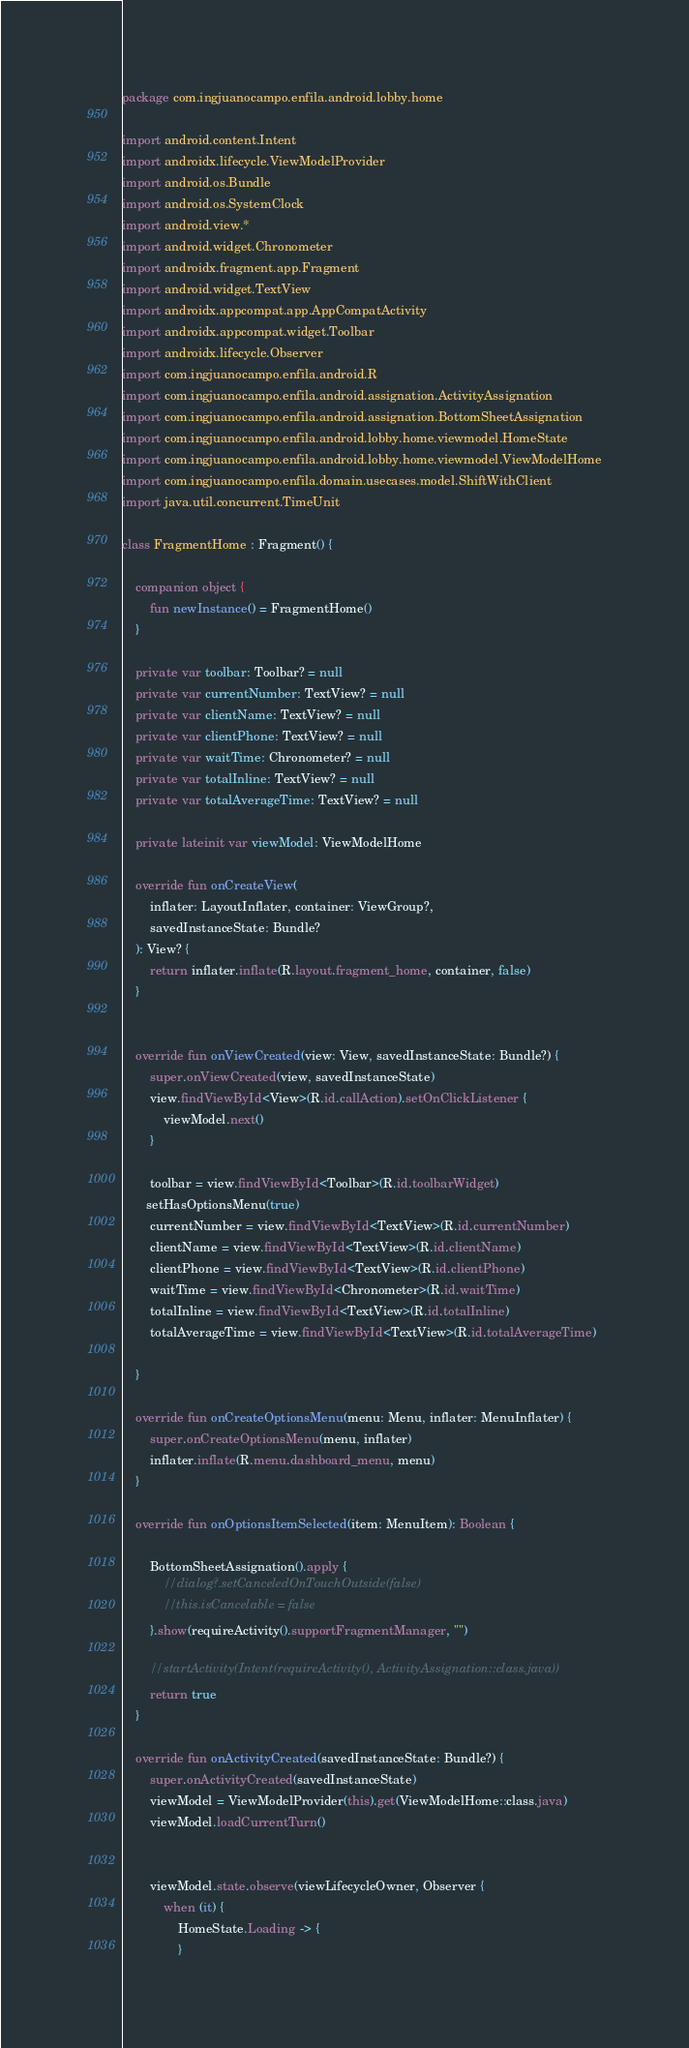<code> <loc_0><loc_0><loc_500><loc_500><_Kotlin_>package com.ingjuanocampo.enfila.android.lobby.home

import android.content.Intent
import androidx.lifecycle.ViewModelProvider
import android.os.Bundle
import android.os.SystemClock
import android.view.*
import android.widget.Chronometer
import androidx.fragment.app.Fragment
import android.widget.TextView
import androidx.appcompat.app.AppCompatActivity
import androidx.appcompat.widget.Toolbar
import androidx.lifecycle.Observer
import com.ingjuanocampo.enfila.android.R
import com.ingjuanocampo.enfila.android.assignation.ActivityAssignation
import com.ingjuanocampo.enfila.android.assignation.BottomSheetAssignation
import com.ingjuanocampo.enfila.android.lobby.home.viewmodel.HomeState
import com.ingjuanocampo.enfila.android.lobby.home.viewmodel.ViewModelHome
import com.ingjuanocampo.enfila.domain.usecases.model.ShiftWithClient
import java.util.concurrent.TimeUnit

class FragmentHome : Fragment() {

    companion object {
        fun newInstance() = FragmentHome()
    }

    private var toolbar: Toolbar? = null
    private var currentNumber: TextView? = null
    private var clientName: TextView? = null
    private var clientPhone: TextView? = null
    private var waitTime: Chronometer? = null
    private var totalInline: TextView? = null
    private var totalAverageTime: TextView? = null

    private lateinit var viewModel: ViewModelHome

    override fun onCreateView(
        inflater: LayoutInflater, container: ViewGroup?,
        savedInstanceState: Bundle?
    ): View? {
        return inflater.inflate(R.layout.fragment_home, container, false)
    }


    override fun onViewCreated(view: View, savedInstanceState: Bundle?) {
        super.onViewCreated(view, savedInstanceState)
        view.findViewById<View>(R.id.callAction).setOnClickListener {
            viewModel.next()
        }

        toolbar = view.findViewById<Toolbar>(R.id.toolbarWidget)
       setHasOptionsMenu(true)
        currentNumber = view.findViewById<TextView>(R.id.currentNumber)
        clientName = view.findViewById<TextView>(R.id.clientName)
        clientPhone = view.findViewById<TextView>(R.id.clientPhone)
        waitTime = view.findViewById<Chronometer>(R.id.waitTime)
        totalInline = view.findViewById<TextView>(R.id.totalInline)
        totalAverageTime = view.findViewById<TextView>(R.id.totalAverageTime)

    }

    override fun onCreateOptionsMenu(menu: Menu, inflater: MenuInflater) {
        super.onCreateOptionsMenu(menu, inflater)
        inflater.inflate(R.menu.dashboard_menu, menu)
    }

    override fun onOptionsItemSelected(item: MenuItem): Boolean {

        BottomSheetAssignation().apply {
            //dialog?.setCanceledOnTouchOutside(false)
            //this.isCancelable = false
        }.show(requireActivity().supportFragmentManager, "")

        //startActivity(Intent(requireActivity(), ActivityAssignation::class.java))
        return true
    }

    override fun onActivityCreated(savedInstanceState: Bundle?) {
        super.onActivityCreated(savedInstanceState)
        viewModel = ViewModelProvider(this).get(ViewModelHome::class.java)
        viewModel.loadCurrentTurn()


        viewModel.state.observe(viewLifecycleOwner, Observer {
            when (it) {
                HomeState.Loading -> {
                }</code> 